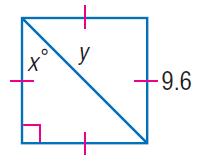Question: Find x.
Choices:
A. 30
B. 37.5
C. 45
D. 90
Answer with the letter. Answer: C Question: Find y.
Choices:
A. 4.8
B. 4.8 \sqrt { 2 }
C. 9.6
D. 9.6 \sqrt { 2 }
Answer with the letter. Answer: D 